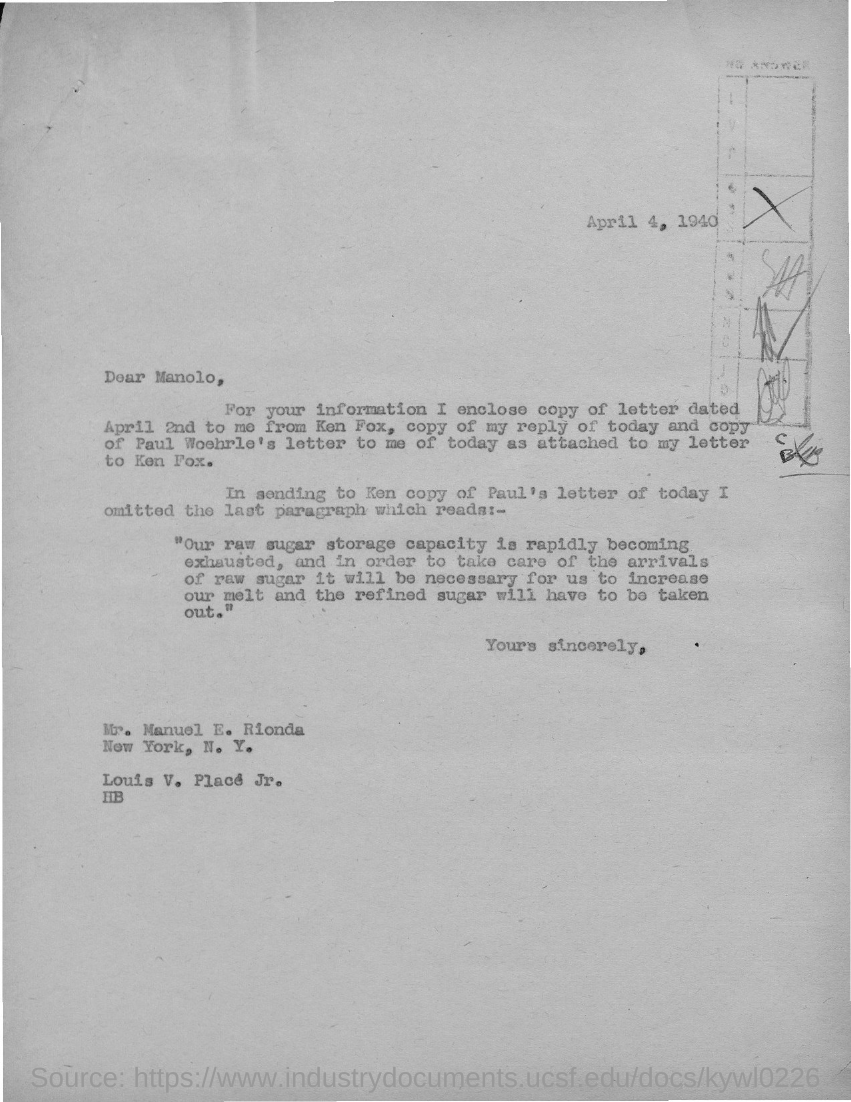To Whom is this letter addressed to?
Keep it short and to the point. Manolo. The enclosed letter is dated on?
Keep it short and to the point. April 2nd. 